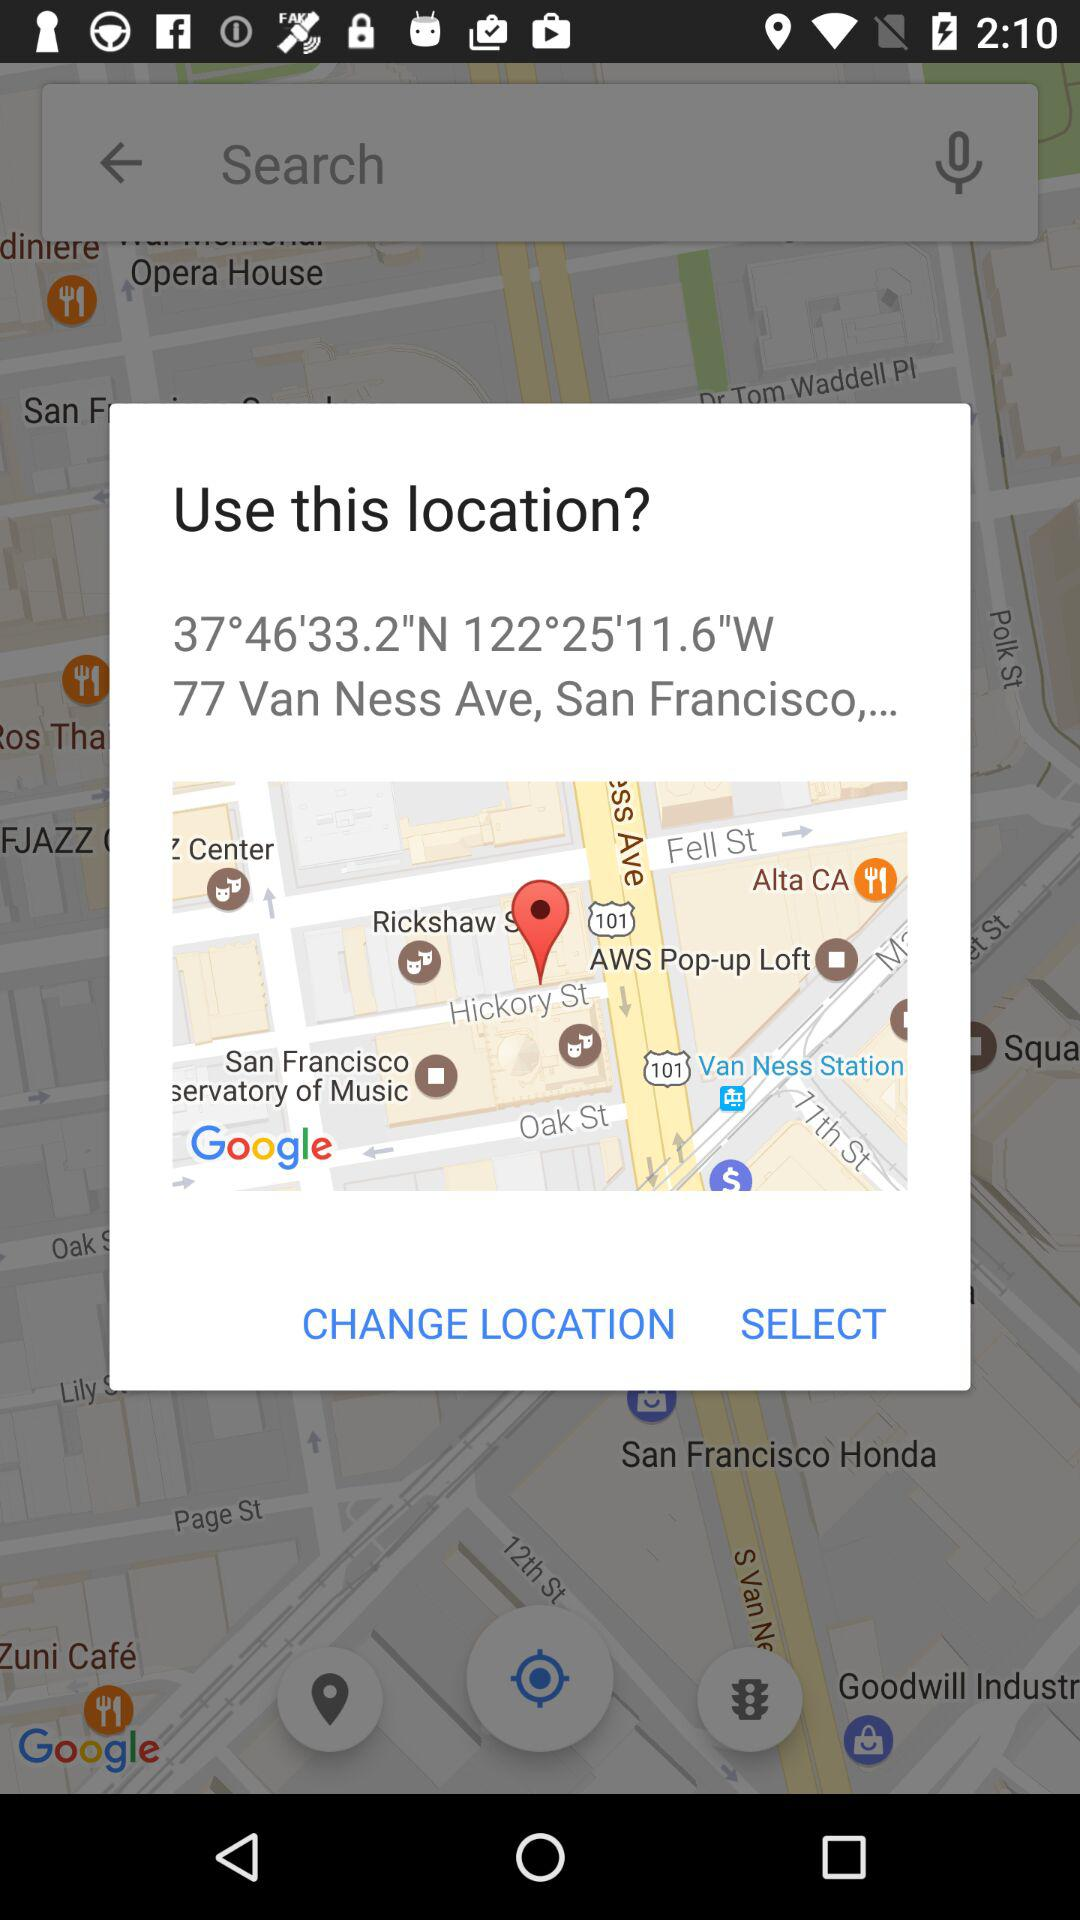What is the location? The location is "77 Van Ness Ave, San Francisco,...". 